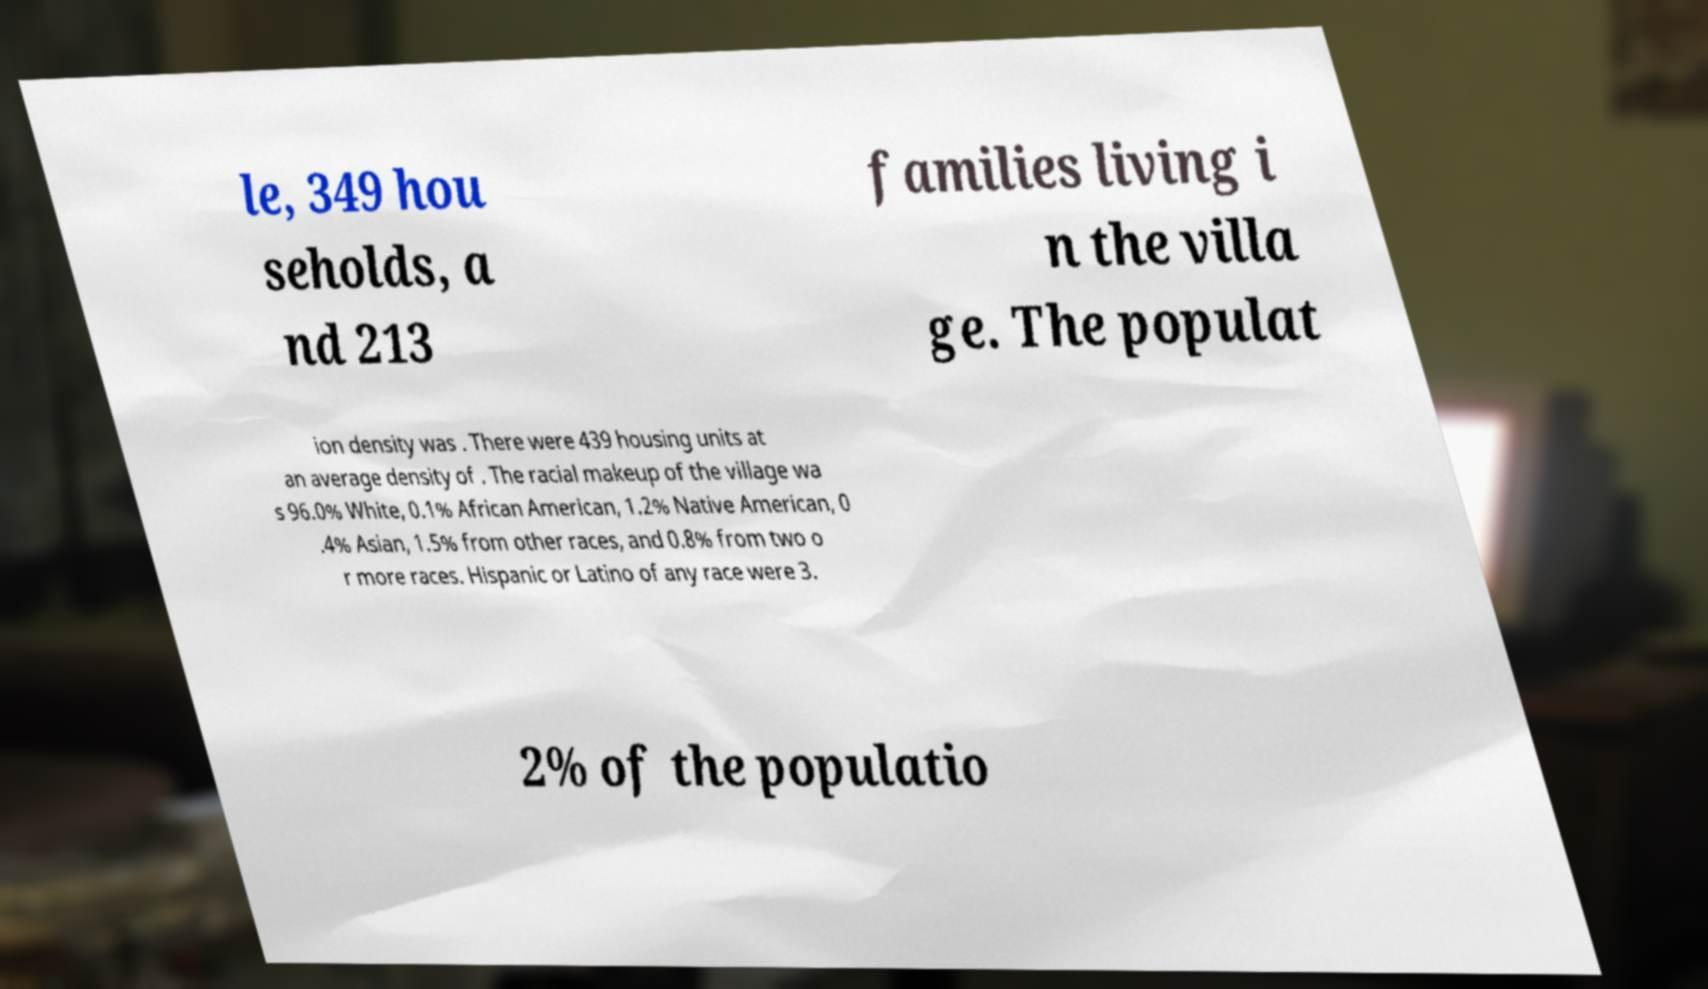I need the written content from this picture converted into text. Can you do that? le, 349 hou seholds, a nd 213 families living i n the villa ge. The populat ion density was . There were 439 housing units at an average density of . The racial makeup of the village wa s 96.0% White, 0.1% African American, 1.2% Native American, 0 .4% Asian, 1.5% from other races, and 0.8% from two o r more races. Hispanic or Latino of any race were 3. 2% of the populatio 